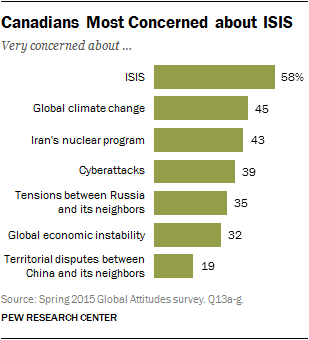Point out several critical features in this image. Research has shown that Canadians are more fearful of ISIS than they are of cyberattacks, with the former being estimated to cause fear at a rate of 0.19 compared to the latter. Canadians' second biggest concern is global climate change. 